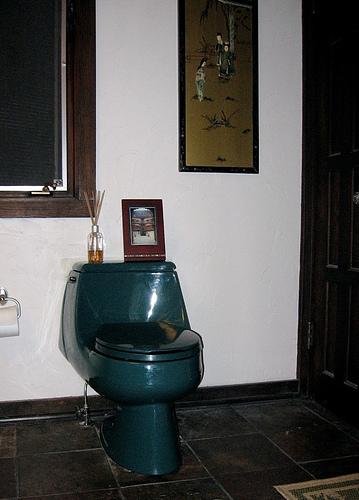<image>How dilapidated is this bathroom? It's ambiguous how dilapidated the bathroom is from the descriptions provided. It varies from slightly dilapidated to not at all. How dilapidated is this bathroom? I don't know how dilapidated the bathroom is. It can be seen as slightly dilapidated or not dilapidated at all. 